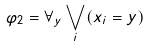<formula> <loc_0><loc_0><loc_500><loc_500>\varphi _ { 2 } = \forall _ { y } \bigvee _ { i } ( x _ { i } = y )</formula> 